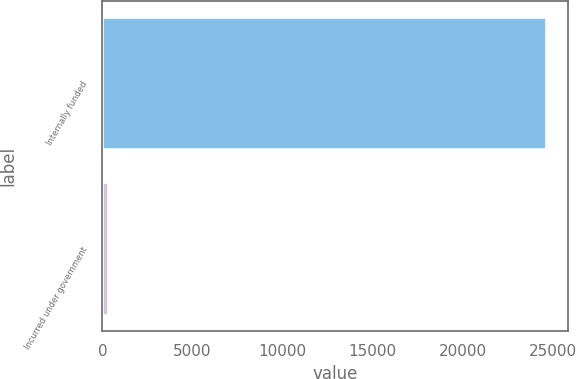Convert chart. <chart><loc_0><loc_0><loc_500><loc_500><bar_chart><fcel>Internally funded<fcel>Incurred under government<nl><fcel>24588<fcel>329<nl></chart> 